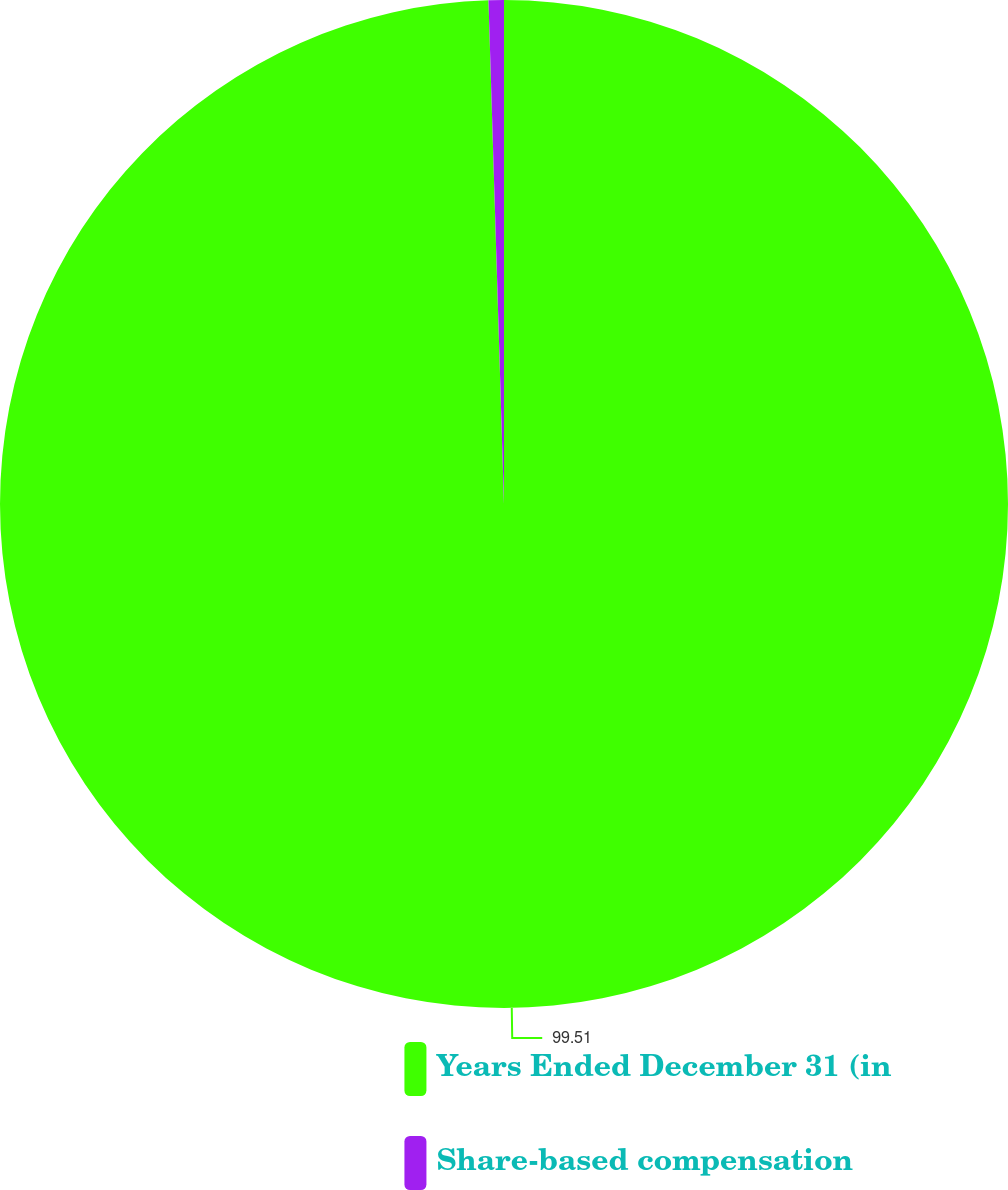<chart> <loc_0><loc_0><loc_500><loc_500><pie_chart><fcel>Years Ended December 31 (in<fcel>Share-based compensation<nl><fcel>99.51%<fcel>0.49%<nl></chart> 